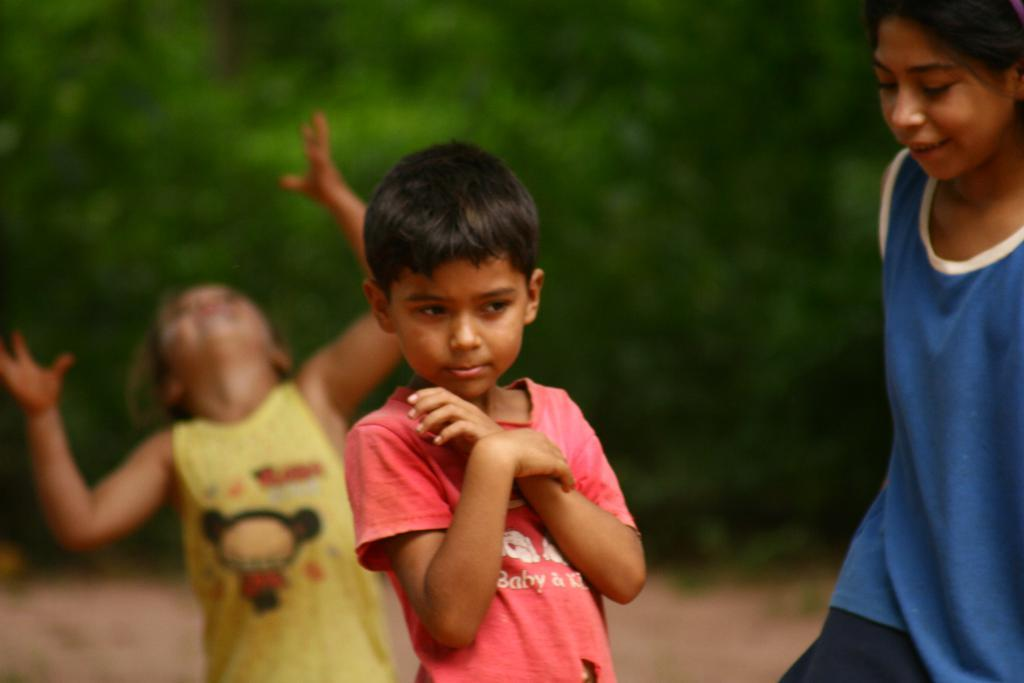How many kids are in the image? There are three kids in the image. Where are the kids located in the image? The kids are standing in the center of the image. What expression do the kids have in the image? The kids are smiling in the image. What can be seen in the background of the image? There are trees in the background of the image. What type of unit is being used to measure the flame in the image? There is no unit or flame present in the image; it features three kids standing and smiling. 